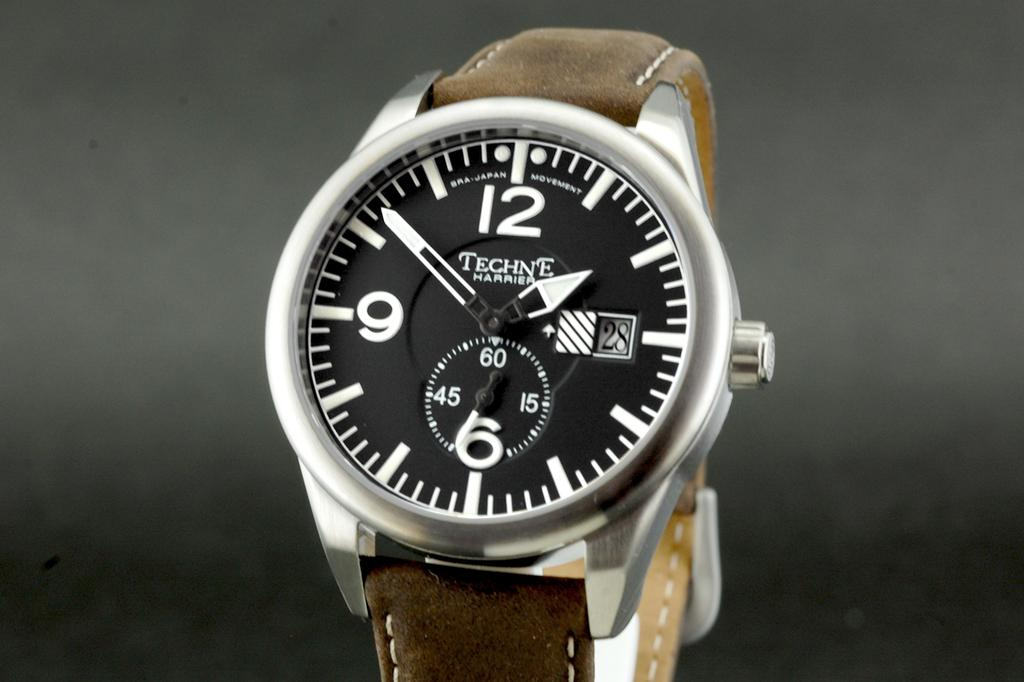Provide a one-sentence caption for the provided image. a Techne Harrier watch with a big face and leather strap. 